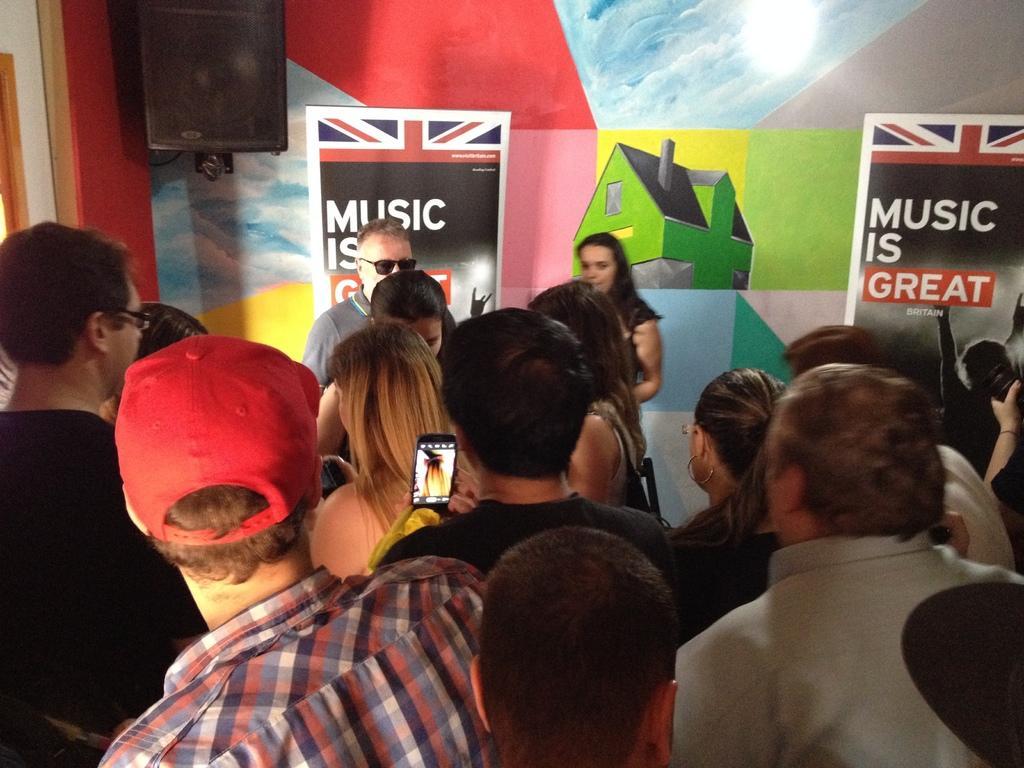How would you summarize this image in a sentence or two? In this image there are people standing and there is a man holding a mobile phone and capturing a photograph. in the background there are banners and there is also a painted wall. Sound box is also visible. 